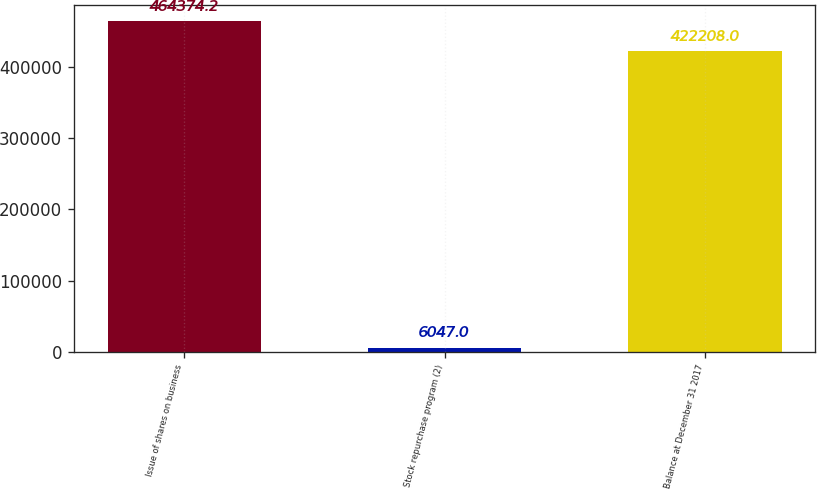Convert chart to OTSL. <chart><loc_0><loc_0><loc_500><loc_500><bar_chart><fcel>Issue of shares on business<fcel>Stock repurchase program (2)<fcel>Balance at December 31 2017<nl><fcel>464374<fcel>6047<fcel>422208<nl></chart> 